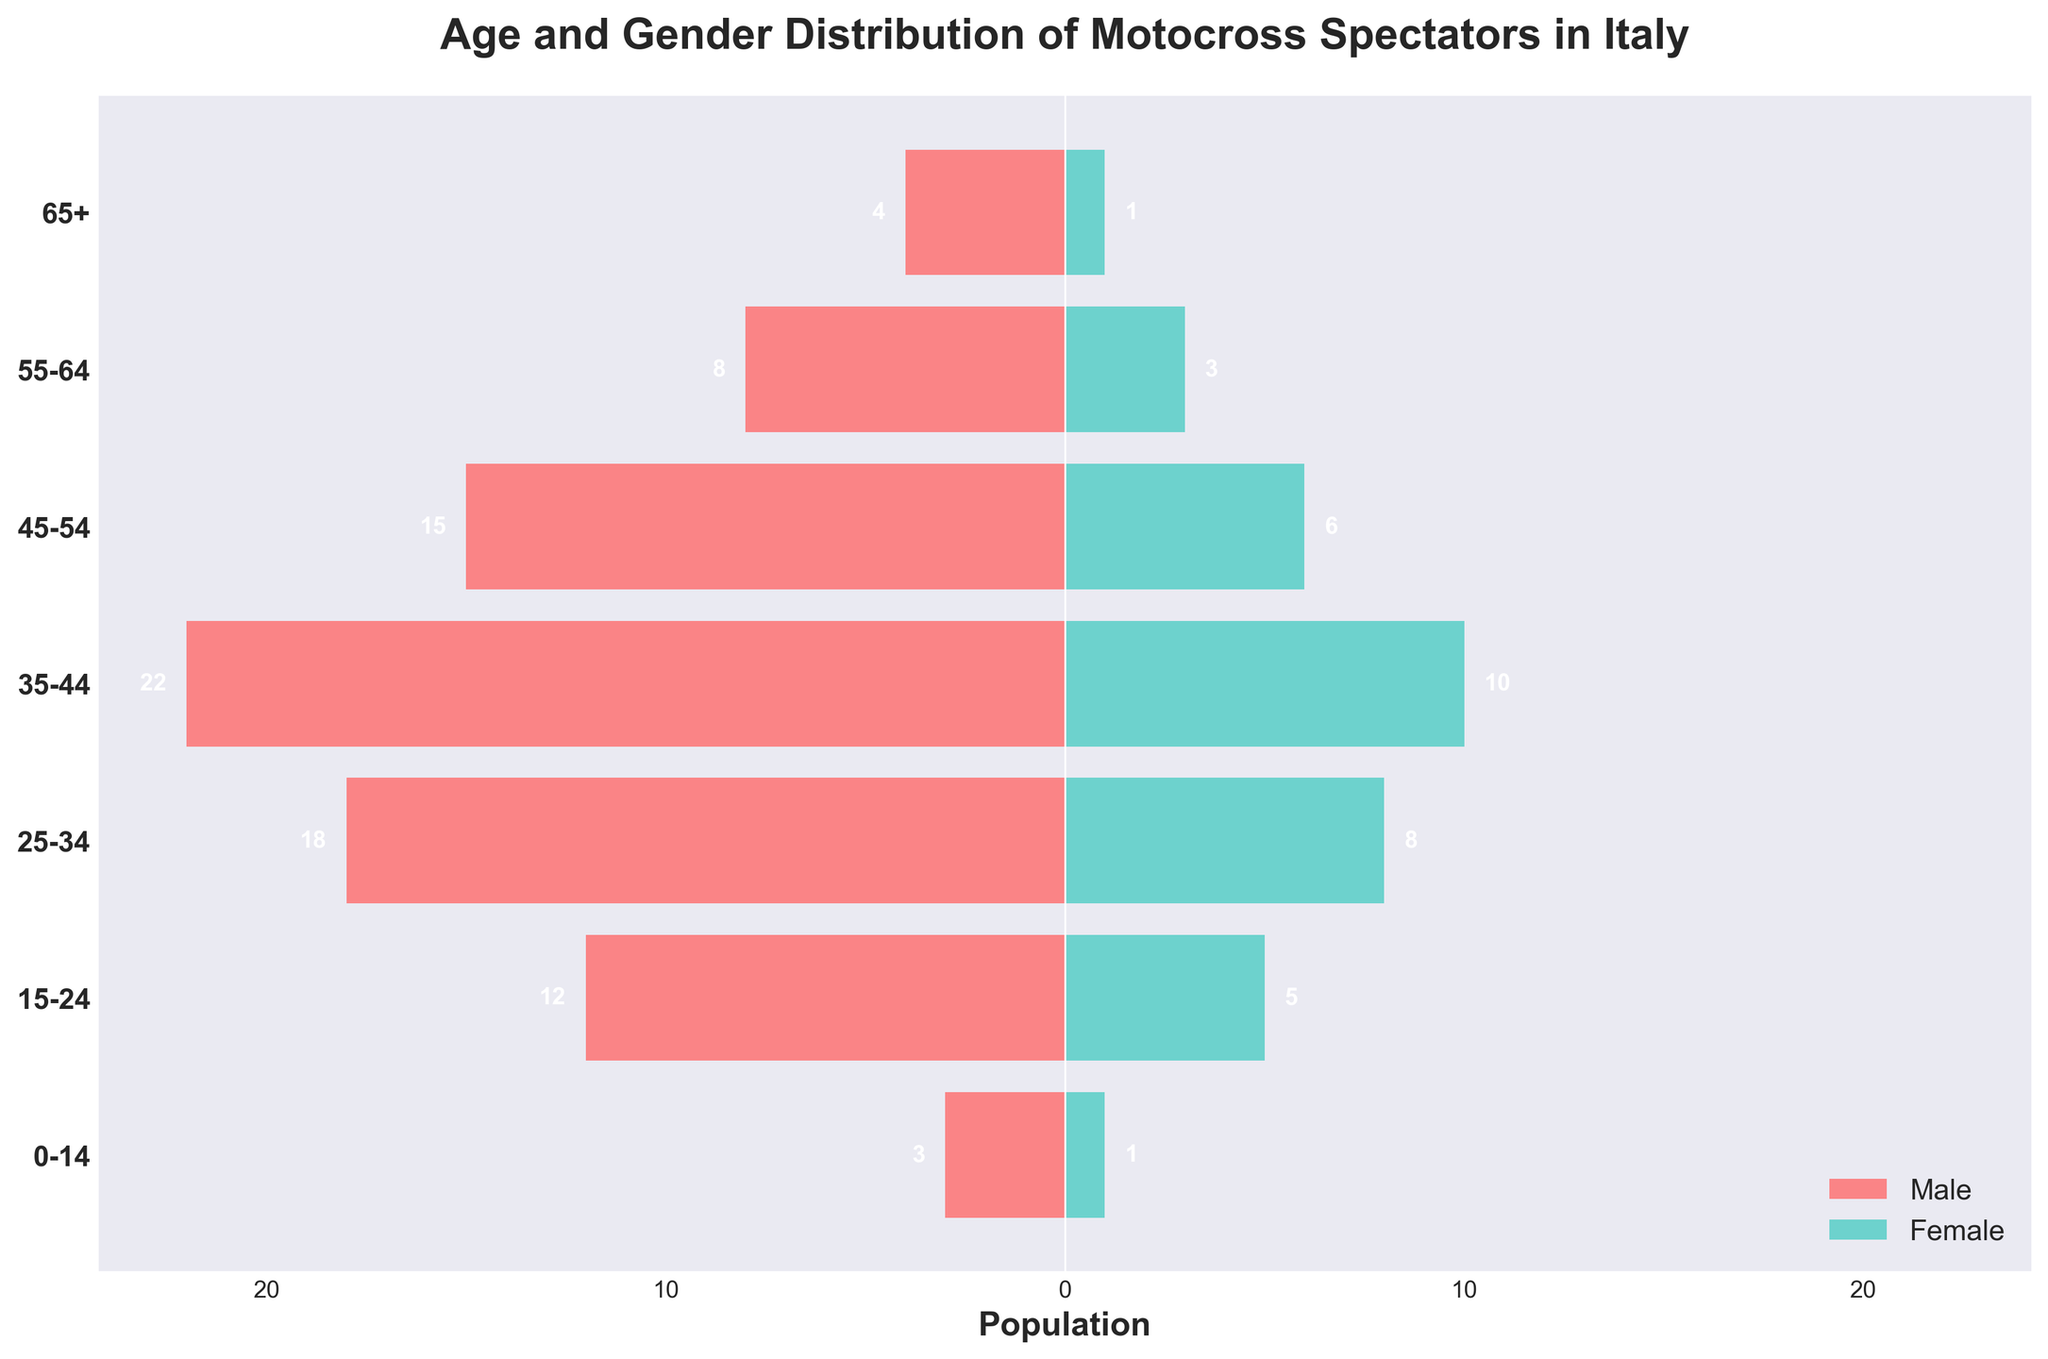What is the title of the figure? The title of the figure is usually found at the top of the chart. In this figure, the title is "Age and Gender Distribution of Motocross Spectators in Italy".
Answer: Age and Gender Distribution of Motocross Spectators in Italy How many age groups are displayed in the figure? The y-axis of the figure lists the age groups. By counting the y-ticks, we see there are seven age groups listed: 0-14, 15-24, 25-34, 35-44, 45-54, 55-64, and 65+.
Answer: Seven Which age group has the highest population of male spectators? By observing the length of the bars on the left side (representing males), the age group 35-44 has the longest bar, indicating the highest number of male spectators.
Answer: 35-44 How many female spectators are in the 45-54 age group? The height of the bar on the right side corresponding to the 45-54 age group shows a value of 6.
Answer: 6 What is the total number of spectators (male and female) in the 25-34 age group? We need to add the value of male spectators and female spectators in the 25-34 age group. Males are 18 and females are 8. Therefore, 18 + 8 = 26.
Answer: 26 What percentage of the total male spectators are aged 35-44? First, we sum the male spectators across all age groups: 3 + 12 + 18 + 22 + 15 + 8 + 4 = 82. The number of males aged 35-44 is 22. So, the percentage is (22/82) * 100 ≈ 26.83%.
Answer: ~26.83% Which gender has more spectators in the 15-24 age group? Comparing the lengths of the bars on both sides for the 15-24 age group, males have 12 and females have 5. Males hence have more spectators.
Answer: Male How many more male spectators are there than female spectators in the 45-54 age group? Subtracting the number of female spectators from male spectators in the 45-54 age group: 15 (male) - 6 (female) = 9.
Answer: 9 What trend can be observed in the number of male spectators as age increases? The bars on the left side (males) generally show an increase until the 35-44 age group, then decrease as age increases.
Answer: Increases then decreases What is the combined number of spectators for age groups 0-14 and 65+? Summing the spectators for both age groups (males and females): (3+1) + (4+1) = 4 + 5 = 9.
Answer: 9 